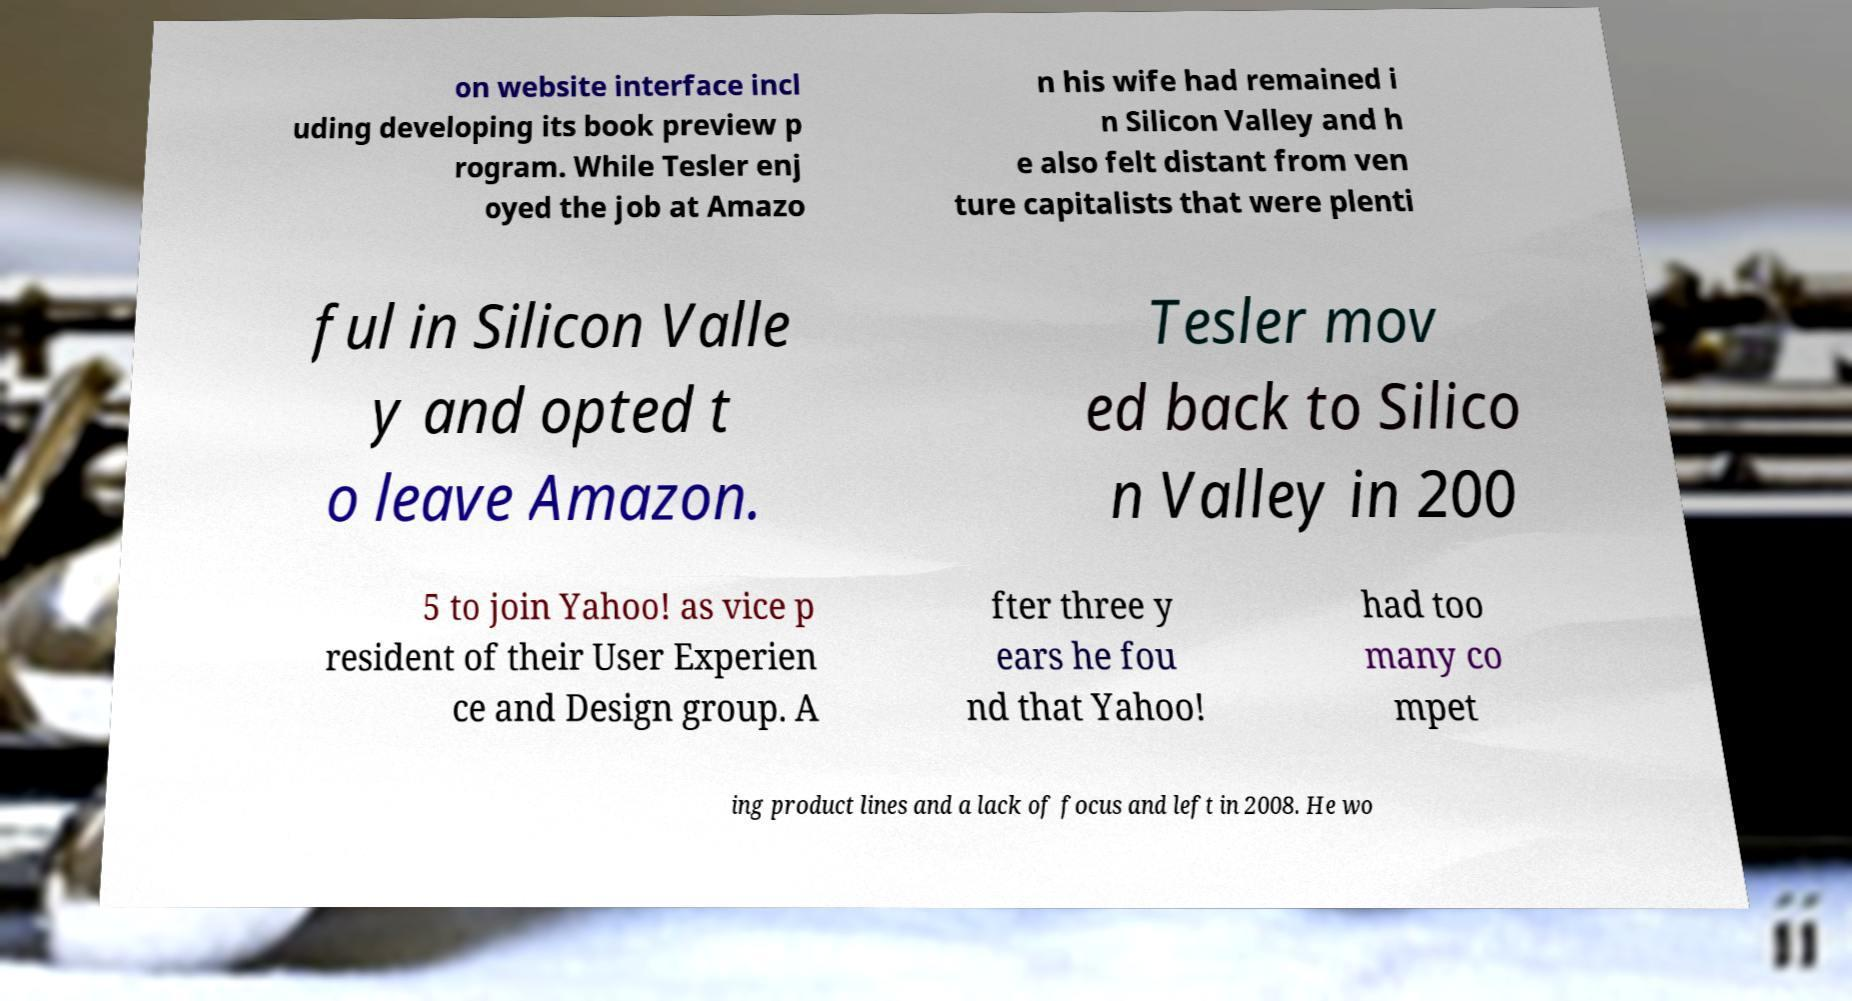There's text embedded in this image that I need extracted. Can you transcribe it verbatim? on website interface incl uding developing its book preview p rogram. While Tesler enj oyed the job at Amazo n his wife had remained i n Silicon Valley and h e also felt distant from ven ture capitalists that were plenti ful in Silicon Valle y and opted t o leave Amazon. Tesler mov ed back to Silico n Valley in 200 5 to join Yahoo! as vice p resident of their User Experien ce and Design group. A fter three y ears he fou nd that Yahoo! had too many co mpet ing product lines and a lack of focus and left in 2008. He wo 